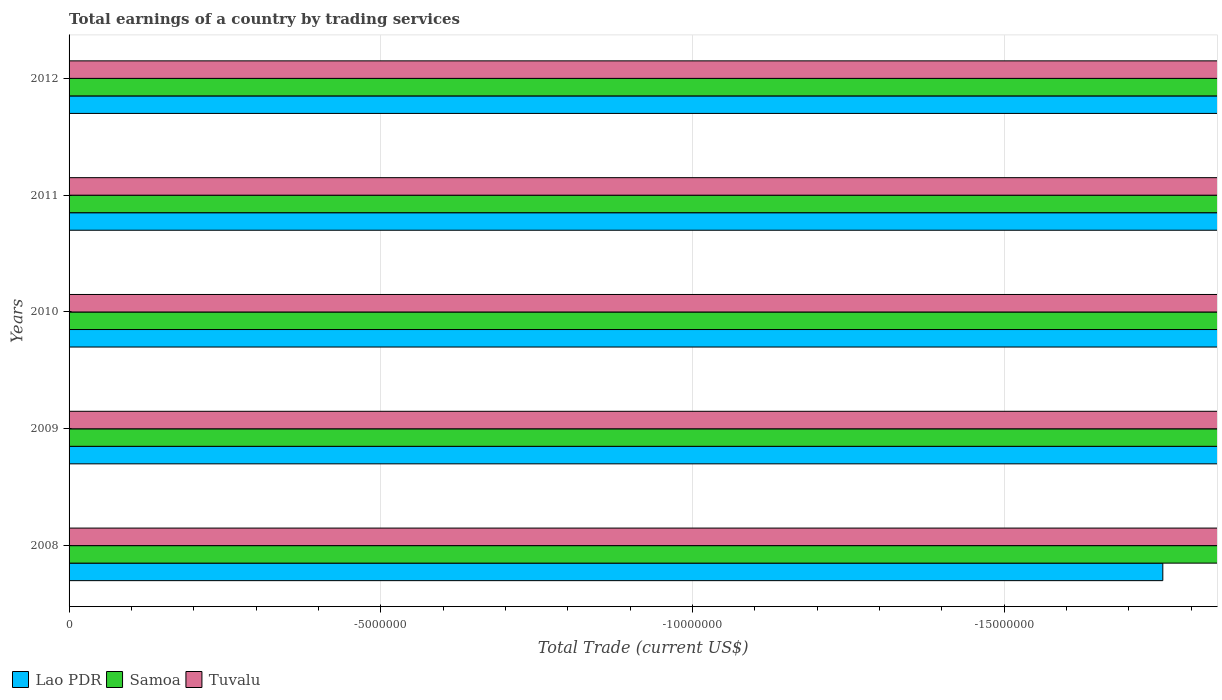How many different coloured bars are there?
Your answer should be very brief. 0. Are the number of bars per tick equal to the number of legend labels?
Give a very brief answer. No. Are the number of bars on each tick of the Y-axis equal?
Your answer should be compact. Yes. How many bars are there on the 1st tick from the top?
Your answer should be compact. 0. How many bars are there on the 5th tick from the bottom?
Make the answer very short. 0. What is the label of the 2nd group of bars from the top?
Your answer should be very brief. 2011. What is the total earnings in Tuvalu in 2008?
Give a very brief answer. 0. What is the total total earnings in Tuvalu in the graph?
Your answer should be very brief. 0. What is the difference between the total earnings in Samoa in 2010 and the total earnings in Tuvalu in 2011?
Offer a terse response. 0. In how many years, is the total earnings in Tuvalu greater than -2000000 US$?
Your response must be concise. 0. Is it the case that in every year, the sum of the total earnings in Lao PDR and total earnings in Samoa is greater than the total earnings in Tuvalu?
Offer a very short reply. No. How many bars are there?
Give a very brief answer. 0. Are all the bars in the graph horizontal?
Your answer should be compact. Yes. How many years are there in the graph?
Your answer should be very brief. 5. Are the values on the major ticks of X-axis written in scientific E-notation?
Your answer should be compact. No. Does the graph contain any zero values?
Your answer should be compact. Yes. Does the graph contain grids?
Offer a very short reply. Yes. What is the title of the graph?
Make the answer very short. Total earnings of a country by trading services. What is the label or title of the X-axis?
Your answer should be compact. Total Trade (current US$). What is the Total Trade (current US$) in Lao PDR in 2009?
Give a very brief answer. 0. What is the Total Trade (current US$) in Samoa in 2009?
Offer a terse response. 0. What is the Total Trade (current US$) of Tuvalu in 2009?
Provide a succinct answer. 0. What is the Total Trade (current US$) of Tuvalu in 2011?
Offer a terse response. 0. What is the Total Trade (current US$) of Lao PDR in 2012?
Offer a terse response. 0. What is the total Total Trade (current US$) in Lao PDR in the graph?
Give a very brief answer. 0. What is the total Total Trade (current US$) of Samoa in the graph?
Give a very brief answer. 0. What is the average Total Trade (current US$) of Lao PDR per year?
Your answer should be very brief. 0. 